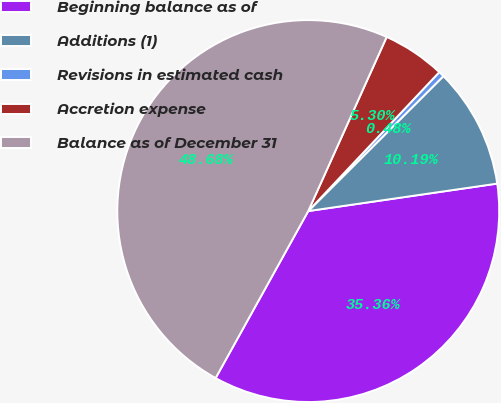Convert chart to OTSL. <chart><loc_0><loc_0><loc_500><loc_500><pie_chart><fcel>Beginning balance as of<fcel>Additions (1)<fcel>Revisions in estimated cash<fcel>Accretion expense<fcel>Balance as of December 31<nl><fcel>35.36%<fcel>10.19%<fcel>0.48%<fcel>5.3%<fcel>48.68%<nl></chart> 